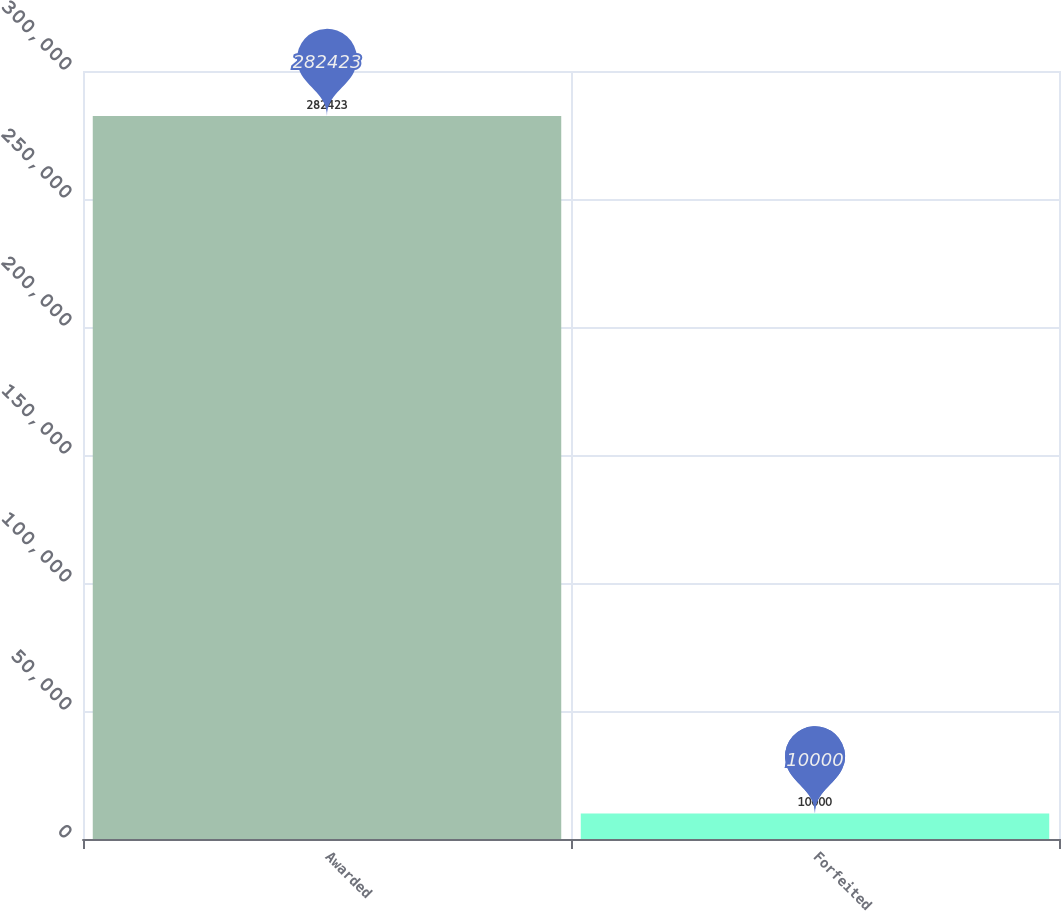Convert chart. <chart><loc_0><loc_0><loc_500><loc_500><bar_chart><fcel>Awarded<fcel>Forfeited<nl><fcel>282423<fcel>10000<nl></chart> 